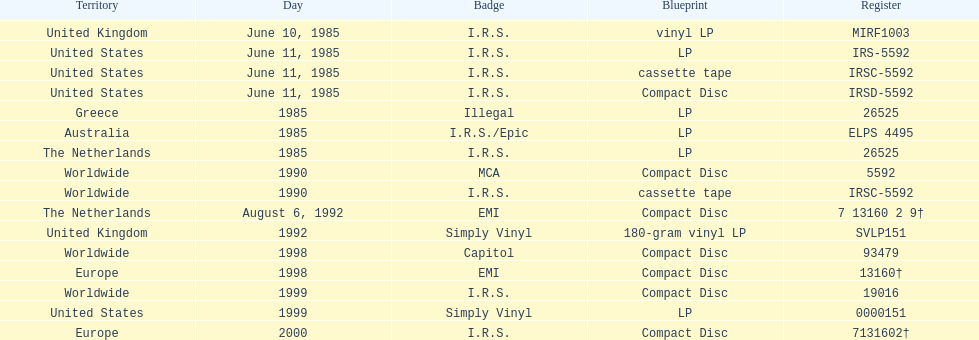In which country or territory were the most releases observed? Worldwide. 